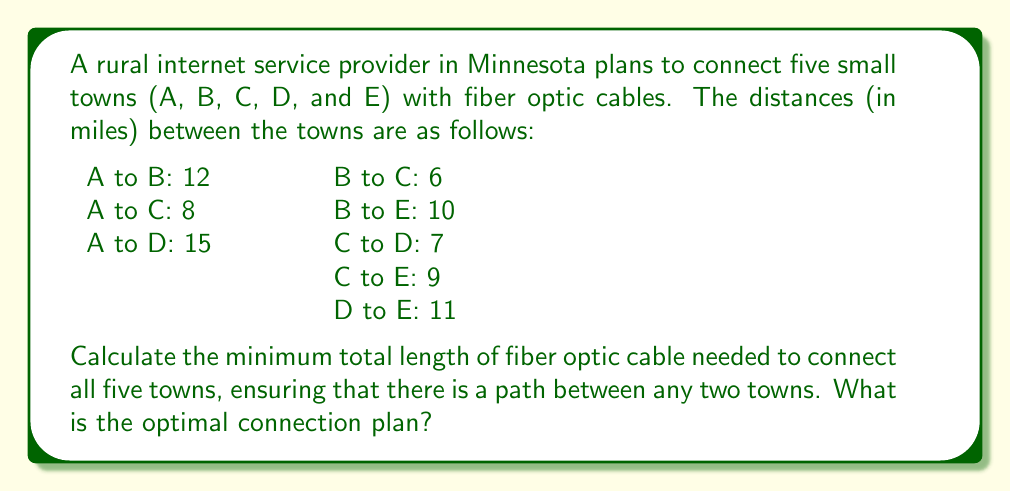Could you help me with this problem? To solve this problem, we need to find the minimum spanning tree (MST) of the graph representing the towns and their connections. We'll use Kruskal's algorithm to find the MST.

Step 1: Sort the edges by weight (distance) in ascending order:
1. B to C: 6
2. C to D: 7
3. A to C: 8
4. C to E: 9
5. B to E: 10
6. D to E: 11
7. A to B: 12
8. A to D: 15

Step 2: Initialize a disjoint set for each town: {A}, {B}, {C}, {D}, {E}

Step 3: Iterate through the sorted edges, adding them to the MST if they don't create a cycle:

1. B to C (6 miles): Add to MST, merge sets {B} and {C}
   MST: {(B,C)}, Total length: 6 miles
   Sets: {A}, {B,C}, {D}, {E}

2. C to D (7 miles): Add to MST, merge sets {B,C} and {D}
   MST: {(B,C), (C,D)}, Total length: 13 miles
   Sets: {A}, {B,C,D}, {E}

3. A to C (8 miles): Add to MST, merge sets {A} and {B,C,D}
   MST: {(B,C), (C,D), (A,C)}, Total length: 21 miles
   Sets: {A,B,C,D}, {E}

4. C to E (9 miles): Add to MST, merge sets {A,B,C,D} and {E}
   MST: {(B,C), (C,D), (A,C), (C,E)}, Total length: 30 miles
   Sets: {A,B,C,D,E}

At this point, all towns are connected, so we stop the algorithm.

The minimum spanning tree consists of the following connections:
1. B to C: 6 miles
2. C to D: 7 miles
3. A to C: 8 miles
4. C to E: 9 miles

The total length of fiber optic cable needed is 30 miles.
Answer: The minimum total length of fiber optic cable needed to connect all five towns is 30 miles. The optimal connection plan is:
1. Connect B to C (6 miles)
2. Connect C to D (7 miles)
3. Connect A to C (8 miles)
4. Connect C to E (9 miles) 